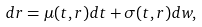Convert formula to latex. <formula><loc_0><loc_0><loc_500><loc_500>d r = \mu ( t , r ) d t + \sigma ( t , r ) d w ,</formula> 